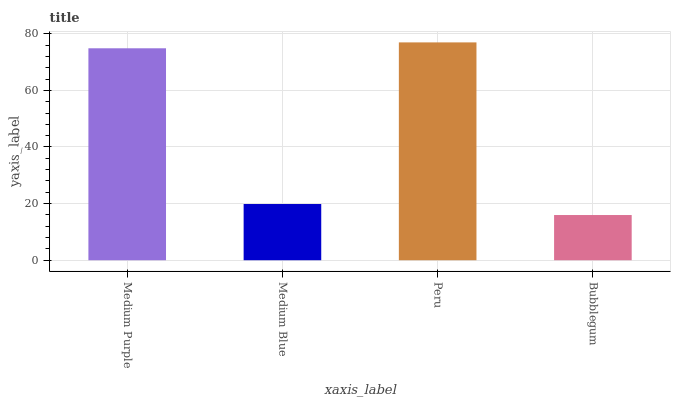Is Bubblegum the minimum?
Answer yes or no. Yes. Is Peru the maximum?
Answer yes or no. Yes. Is Medium Blue the minimum?
Answer yes or no. No. Is Medium Blue the maximum?
Answer yes or no. No. Is Medium Purple greater than Medium Blue?
Answer yes or no. Yes. Is Medium Blue less than Medium Purple?
Answer yes or no. Yes. Is Medium Blue greater than Medium Purple?
Answer yes or no. No. Is Medium Purple less than Medium Blue?
Answer yes or no. No. Is Medium Purple the high median?
Answer yes or no. Yes. Is Medium Blue the low median?
Answer yes or no. Yes. Is Bubblegum the high median?
Answer yes or no. No. Is Bubblegum the low median?
Answer yes or no. No. 